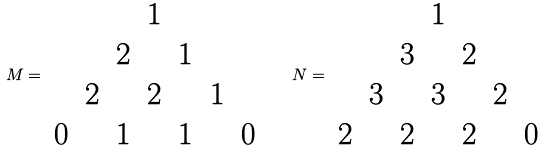<formula> <loc_0><loc_0><loc_500><loc_500>M = \begin{array} { c c c c c c c } & & & 1 & & & \\ & & 2 & & 1 & & \\ & 2 & & 2 & & 1 & \\ 0 & & 1 & & 1 & & 0 \\ \end{array} \quad N = \begin{array} { c c c c c c c } & & & 1 & & & \\ & & 3 & & 2 & & \\ & 3 & & 3 & & 2 & \\ 2 & & 2 & & 2 & & 0 \\ \end{array}</formula> 